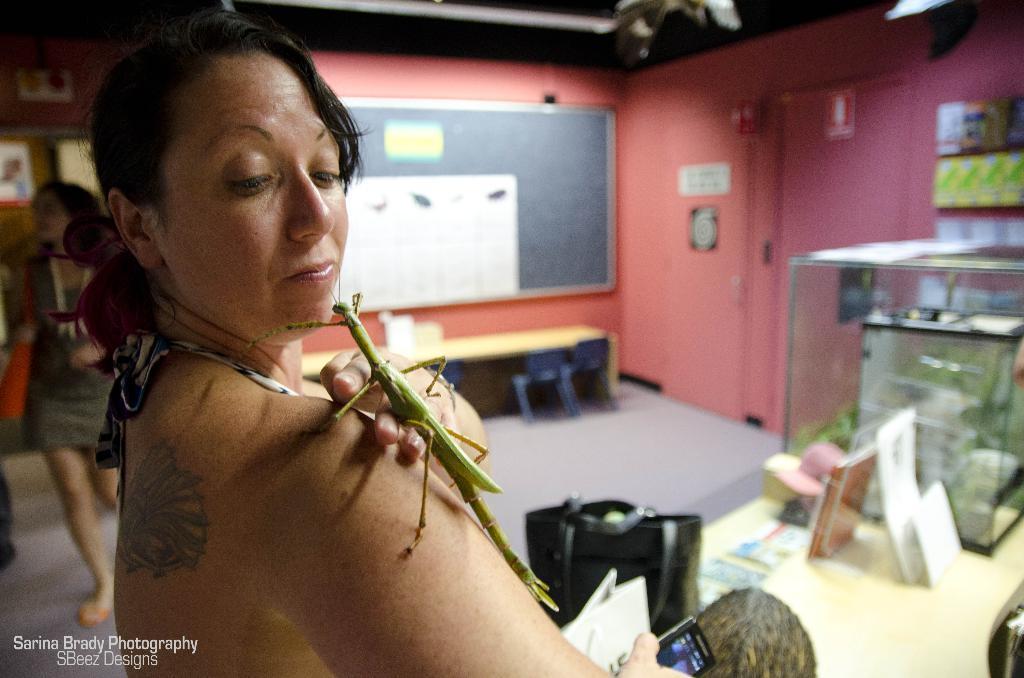Could you give a brief overview of what you see in this image? In the foreground of this image, there is a woman holding a mobile in her hand and a grasshopper is on her shoulder. In front her, there is a table on which there are bags, calendars and a glass object. In the background, there is a wall, few frames like an object on the wall, a black board, table, chairs, a woman walking on the ground and few frames on the wall. 